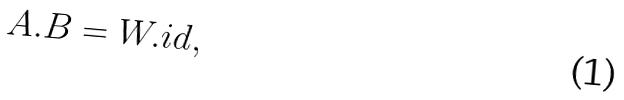Convert formula to latex. <formula><loc_0><loc_0><loc_500><loc_500>A . B = W . i d ,</formula> 